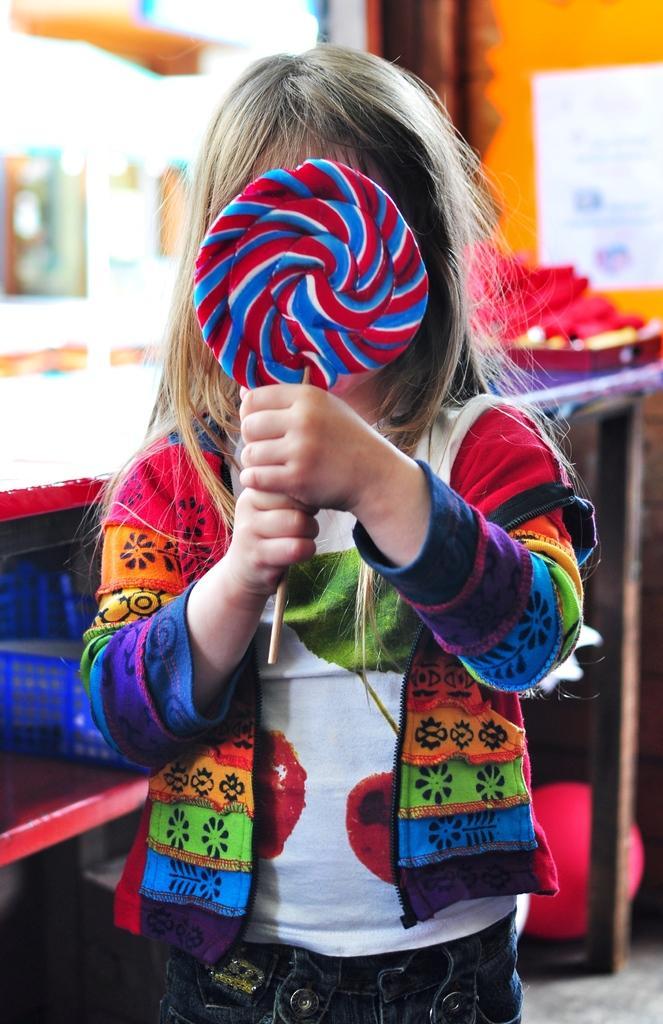How would you summarize this image in a sentence or two? In this image we can see a kid standing and holding a lollipop and there is a basket on the object looks like a rock and a blurry background. 